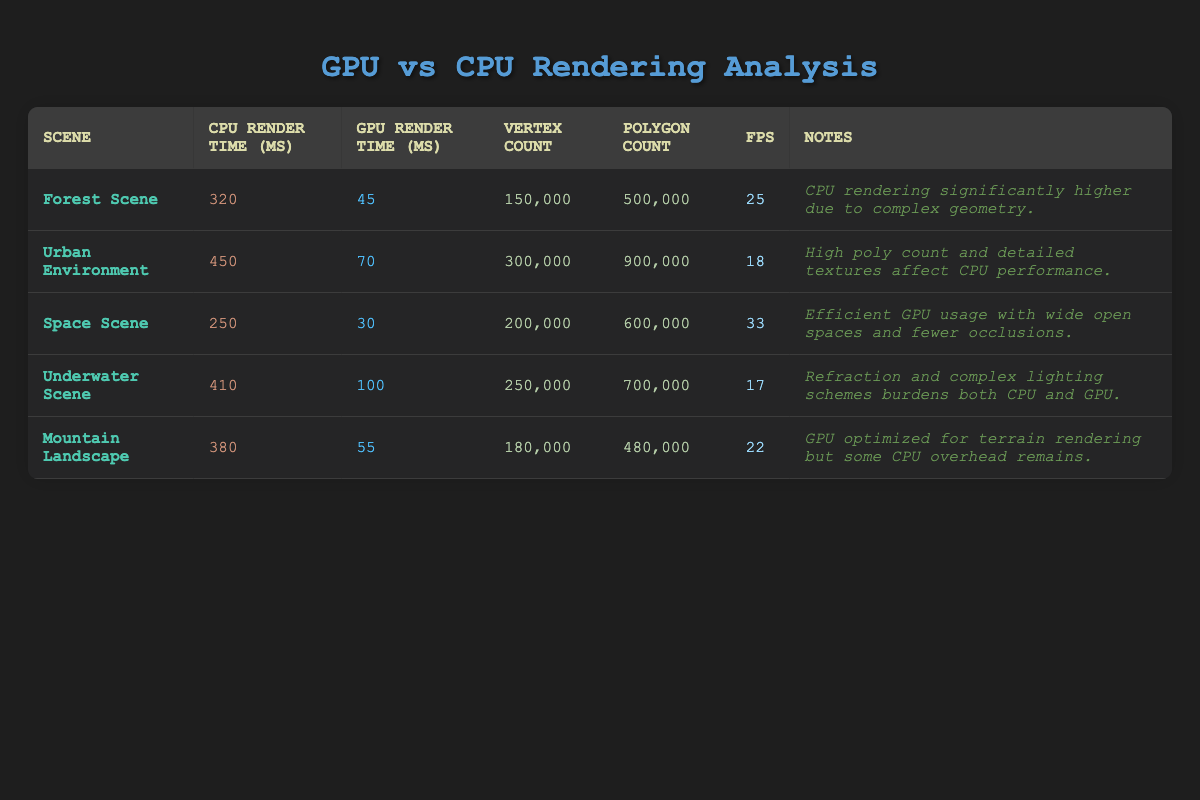What is the GPU render time for the Space Scene? The GPU render time for the Space Scene is directly stated in the table under the "GPU Render Time (ms)" column. Looking at the row for the Space Scene, the value is 30 ms.
Answer: 30 ms What is the difference between the CPU render time for the Forest Scene and the Urban Environment? To find the difference, we subtract the CPU render time of the Forest Scene from that of the Urban Environment. The CPU render time for the Forest Scene is 320 ms, and for the Urban Environment, it is 450 ms. Therefore, the difference is 450 - 320 = 130 ms.
Answer: 130 ms What is the maximum FPS recorded across all scenes? The FPS values for each scene are 25, 18, 33, 17, and 22. To find the maximum, we compare these values and determine that 33 is the highest value.
Answer: 33 Is the CPU render time for the Underwater Scene less than the CPU render time for the Mountain Landscape? The CPU render time for the Underwater Scene is 410 ms, while the Mountain Landscape has a CPU render time of 380 ms. Since 410 is greater than 380, the statement is false.
Answer: No How many total vertexes are present across all scenes combined? To get the total number of vertexes, we need to add the vertex counts from all scenes: 150,000 + 300,000 + 200,000 + 250,000 + 180,000 = 1,080,000. We perform the addition step-by-step to ensure accuracy.
Answer: 1,080,000 What scene has the highest polygon count? By examining the "Polygon Count" column, we find that the values are 500,000, 900,000, 600,000, 700,000, and 480,000. The highest value is 900,000, which corresponds to the Urban Environment.
Answer: Urban Environment Is the GPU render time for the Mountain Landscape scene higher than that of the Space Scene? The GPU render time for the Mountain Landscape is 55 ms, and for the Space Scene, it is 30 ms. Since 55 is greater than 30, the statement is true.
Answer: Yes What is the average CPU render time for all scenes? To calculate the average CPU render time, we first sum the CPU render times: 320 + 450 + 250 + 410 + 380 = 1,810 ms. Next, we divide this sum by the number of scenes, which is 5. Therefore, the average CPU render time is 1,810 / 5 = 362 ms.
Answer: 362 ms What are the notes associated with the Space Scene? The notes for the Space Scene are mentioned in the "Notes" column of the table for that scene, which states that the efficient GPU usage is due to wide open spaces and fewer occlusions.
Answer: Efficient GPU usage with wide open spaces and fewer occlusions 